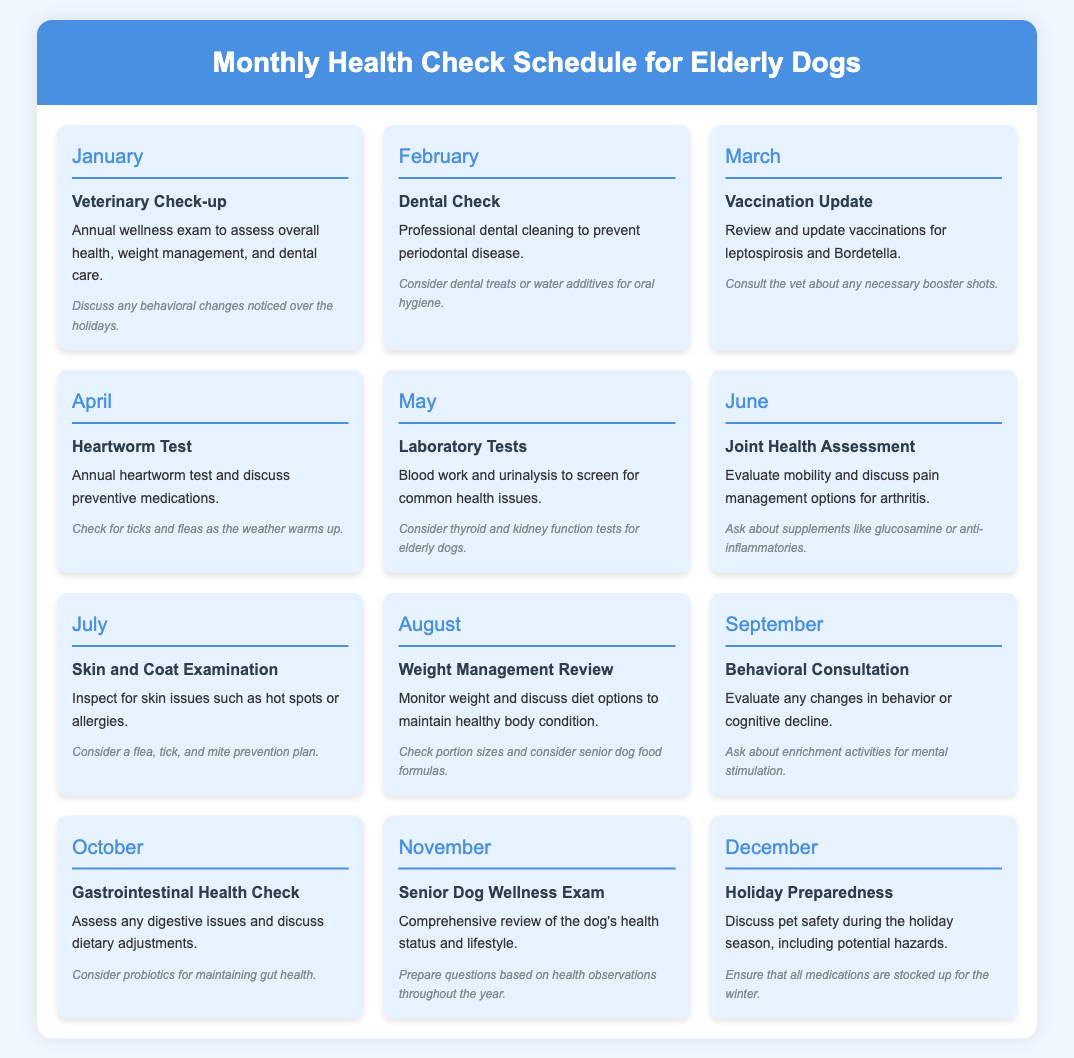What month is designated for the Veterinary Check-up? The document specifies that the Veterinary Check-up occurs in January.
Answer: January What type of check-up is scheduled for February? According to the document, February is designated for a Dental Check.
Answer: Dental Check What is the primary focus of the March check-up? The check-up in March focuses on reviewing and updating vaccinations.
Answer: Vaccination Update Which month includes a skin and coat examination? The document states that the skin and coat examination takes place in July.
Answer: July What preventative care is discussed in April? In April, an annual heartworm test and preventive medications are discussed.
Answer: Heartworm Test How many months focus on dietary assessments? The document includes two months that focus on dietary assessments: May for laboratory tests and August for weight management review.
Answer: Two What is one of the goals of the November check-up? The November check-up aims to provide a comprehensive review of the dog's health status.
Answer: Comprehensive review Which month addresses behavioral issues? September is the month designated for evaluating behavioral changes or cognitive decline.
Answer: September 